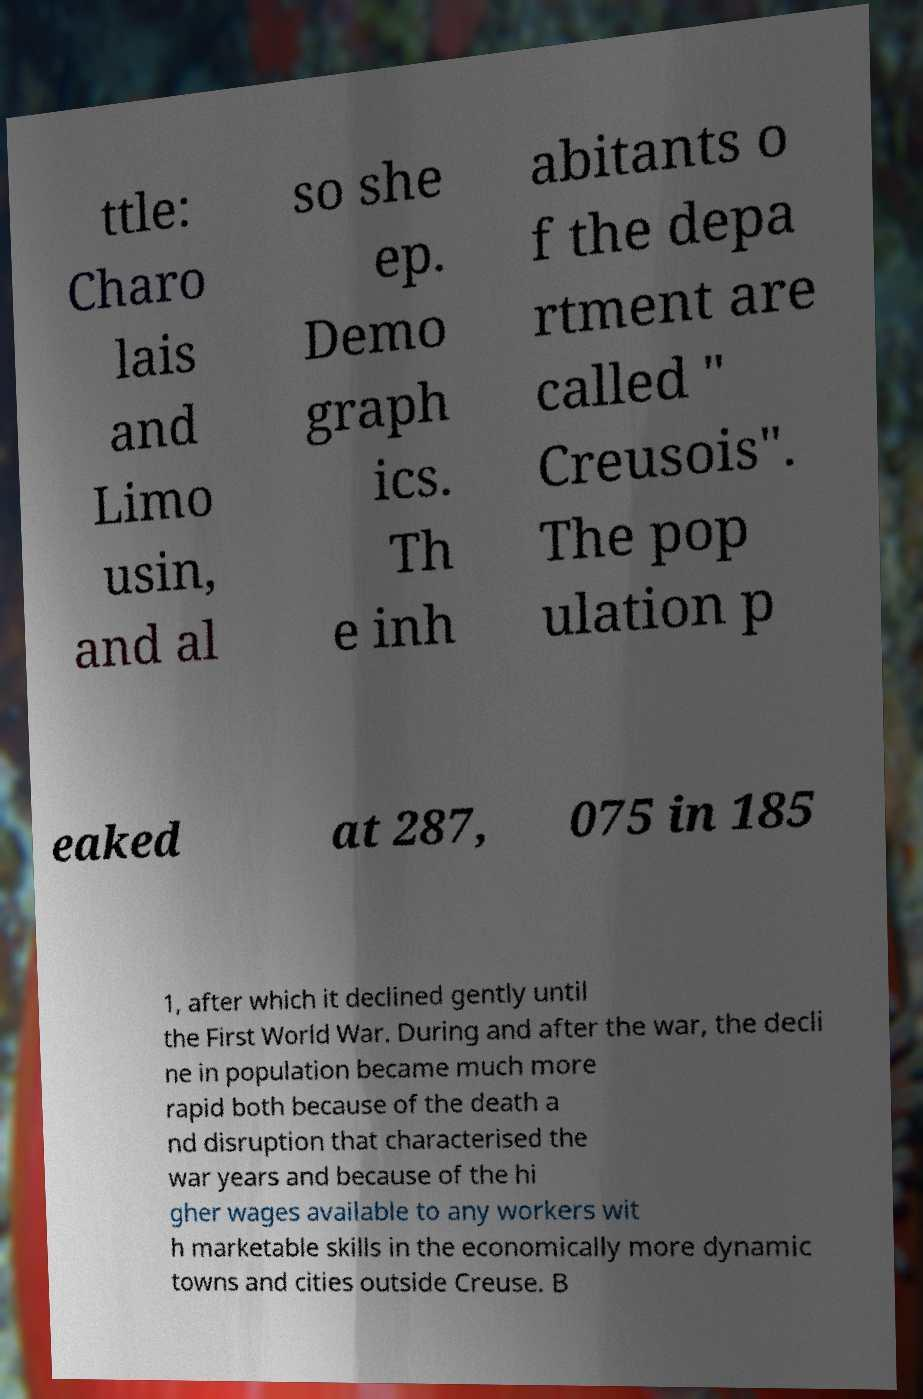There's text embedded in this image that I need extracted. Can you transcribe it verbatim? ttle: Charo lais and Limo usin, and al so she ep. Demo graph ics. Th e inh abitants o f the depa rtment are called " Creusois". The pop ulation p eaked at 287, 075 in 185 1, after which it declined gently until the First World War. During and after the war, the decli ne in population became much more rapid both because of the death a nd disruption that characterised the war years and because of the hi gher wages available to any workers wit h marketable skills in the economically more dynamic towns and cities outside Creuse. B 